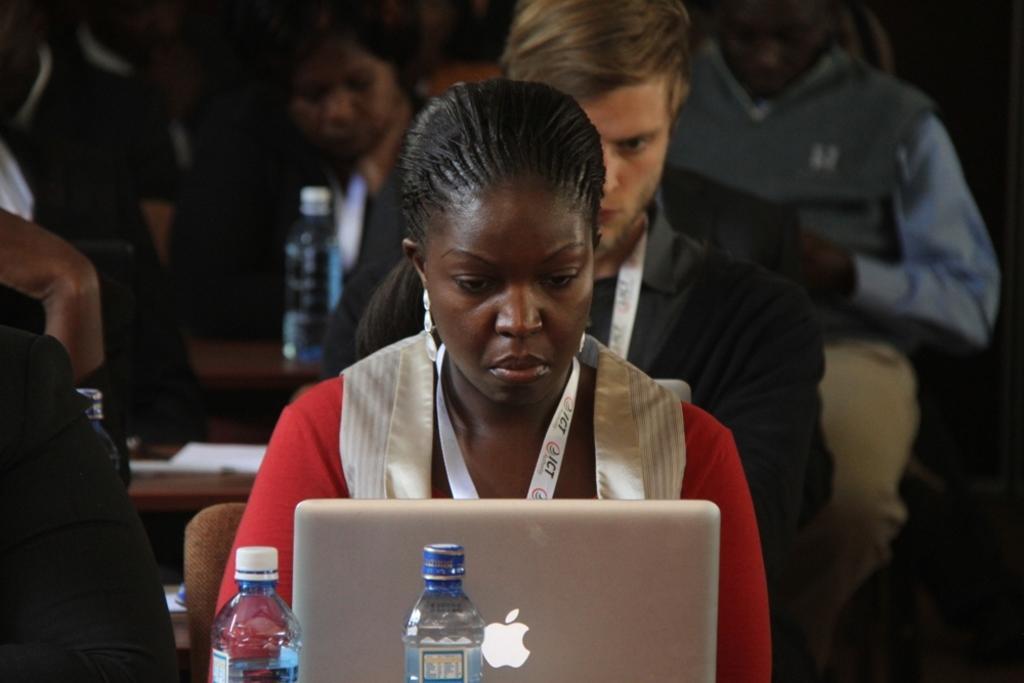Can you describe this image briefly? In this image I can see number of people are sitting. I can also see few tables and on these tables I can see a laptop and few bottles. 